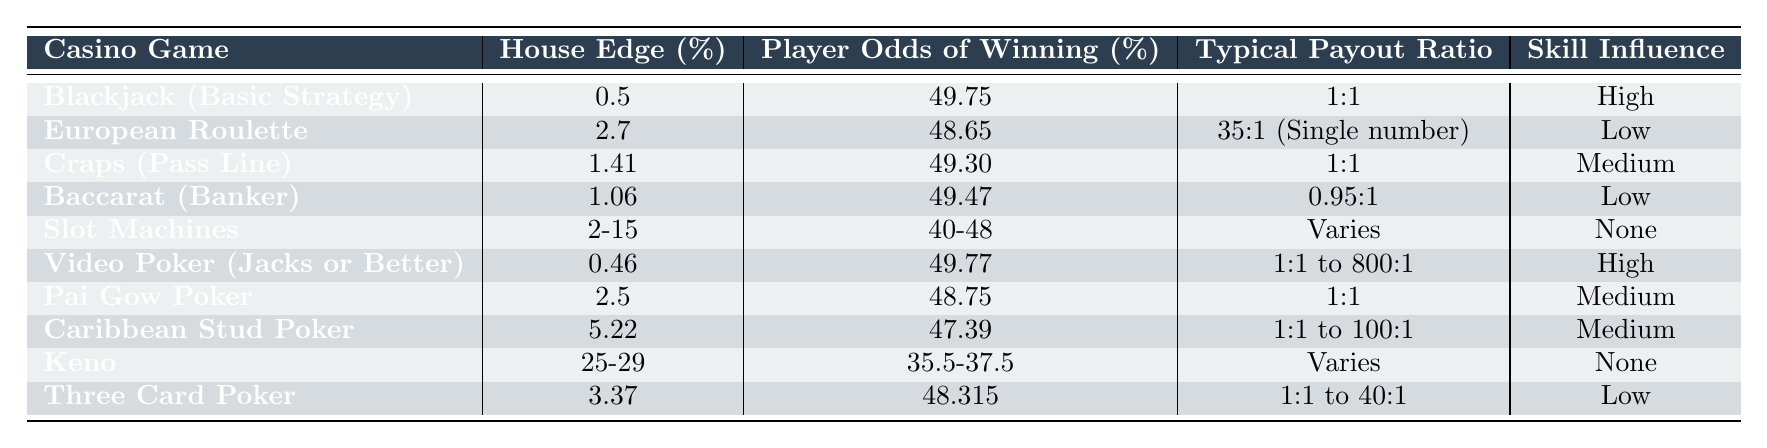What is the house edge for Video Poker (Jacks or Better)? By referencing the table, the house edge for Video Poker (Jacks or Better) is listed as 0.46% under the House Edge (%) column.
Answer: 0.46% Which casino game has the highest player odds of winning? Looking at the Player Odds of Winning (%) column, Video Poker (Jacks or Better) has the highest odds at 49.77%.
Answer: Video Poker (Jacks or Better) Is the house edge for European Roulette lower than that of Baccarat (Banker)? The table shows that European Roulette has a house edge of 2.7%, while Baccarat (Banker) has a house edge of 1.06%. Since 2.7% is greater than 1.06%, the statement is false.
Answer: No What is the typical payout ratio for Caribbean Stud Poker? In the Typical Payout Ratio column for Caribbean Stud Poker, it is noted to range from 1:1 to 100:1.
Answer: 1:1 to 100:1 How many games have a house edge lower than 2%? Scanning the House Edge (%) column reveals that only Blackjack (Basic Strategy) at 0.5% and Video Poker (Jacks or Better) at 0.46% fall below 2%, which totals two games.
Answer: 2 Which game offers the highest potential payout ratio? Referring to the table in the Typical Payout Ratio column, Video Poker (Jacks or Better) notes payouts ranging from 1:1 to 800:1, which is the highest potential payout ratio listed.
Answer: Video Poker (Jacks or Better) What is the average house edge for the games listed in the table? To find the average house edge, add the house edges of non-slot games: 0.5 + 2.7 + 1.41 + 1.06 + 2.5 + 5.22 + 3.37, which totals 16.54%. There are 7 games, so the average is 16.54/7 ≈ 2.36%.
Answer: 2.36% Is the skill influence for Slot Machines categorized as medium, high, or low? The Skill Influence for Slot Machines is listed as "None" in the corresponding column, indicating no influence by player skill.
Answer: None Which game has the lowest player odds of winning? The table indicates Keno has the lowest player odds of winning at 35.5% to 37.5%.
Answer: Keno If I compare the player odds for Baccarat (Banker) and Craps (Pass Line), which game has better odds? The odds for Baccarat (Banker) are 49.47% while for Craps (Pass Line) it is 49.30%. Baccarat (Banker) has better odds.
Answer: Baccarat (Banker) 